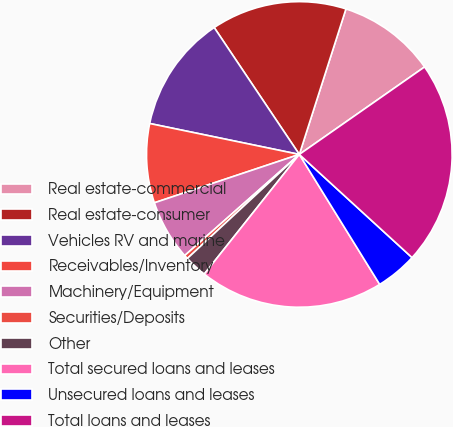Convert chart. <chart><loc_0><loc_0><loc_500><loc_500><pie_chart><fcel>Real estate-commercial<fcel>Real estate-consumer<fcel>Vehicles RV and marine<fcel>Receivables/Inventory<fcel>Machinery/Equipment<fcel>Securities/Deposits<fcel>Other<fcel>Total secured loans and leases<fcel>Unsecured loans and leases<fcel>Total loans and leases<nl><fcel>10.36%<fcel>14.34%<fcel>12.35%<fcel>8.37%<fcel>6.38%<fcel>0.41%<fcel>2.4%<fcel>19.5%<fcel>4.39%<fcel>21.5%<nl></chart> 